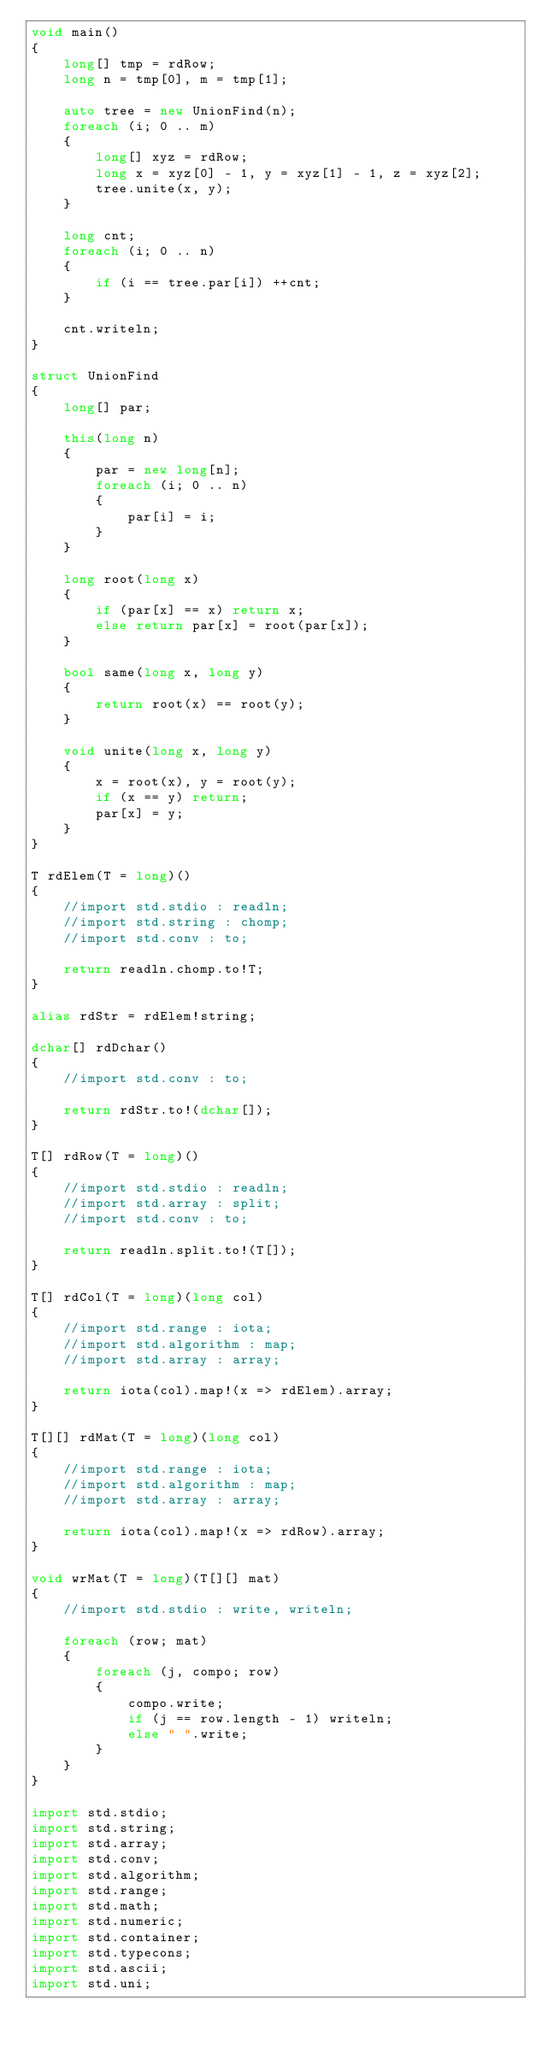Convert code to text. <code><loc_0><loc_0><loc_500><loc_500><_D_>void main()
{
    long[] tmp = rdRow;
    long n = tmp[0], m = tmp[1];

    auto tree = new UnionFind(n);
    foreach (i; 0 .. m)
    {
        long[] xyz = rdRow;
        long x = xyz[0] - 1, y = xyz[1] - 1, z = xyz[2];
        tree.unite(x, y);
    }

    long cnt;
    foreach (i; 0 .. n)
    {
        if (i == tree.par[i]) ++cnt;
    }

    cnt.writeln;
}

struct UnionFind
{
    long[] par;

    this(long n)
    {
        par = new long[n];
        foreach (i; 0 .. n)
        {
            par[i] = i;
        }
    }

    long root(long x)
    {
        if (par[x] == x) return x;
        else return par[x] = root(par[x]);
    }

    bool same(long x, long y)
    {
        return root(x) == root(y);
    }

    void unite(long x, long y)
    {
        x = root(x), y = root(y);
        if (x == y) return;
        par[x] = y;
    }
}

T rdElem(T = long)()
{
    //import std.stdio : readln;
    //import std.string : chomp;
    //import std.conv : to;

    return readln.chomp.to!T;
}

alias rdStr = rdElem!string;

dchar[] rdDchar()
{
    //import std.conv : to;

    return rdStr.to!(dchar[]);
}

T[] rdRow(T = long)()
{
    //import std.stdio : readln;
    //import std.array : split;
    //import std.conv : to;

    return readln.split.to!(T[]);
}

T[] rdCol(T = long)(long col)
{
    //import std.range : iota;
    //import std.algorithm : map;
    //import std.array : array;

    return iota(col).map!(x => rdElem).array;
}

T[][] rdMat(T = long)(long col)
{
    //import std.range : iota;
    //import std.algorithm : map;
    //import std.array : array;

    return iota(col).map!(x => rdRow).array;
}

void wrMat(T = long)(T[][] mat)
{
    //import std.stdio : write, writeln;

    foreach (row; mat)
    {
        foreach (j, compo; row)
        {
            compo.write;
            if (j == row.length - 1) writeln;
            else " ".write;
        }
    }
}

import std.stdio;
import std.string;
import std.array;
import std.conv;
import std.algorithm;
import std.range;
import std.math;
import std.numeric;
import std.container;
import std.typecons;
import std.ascii;
import std.uni;</code> 